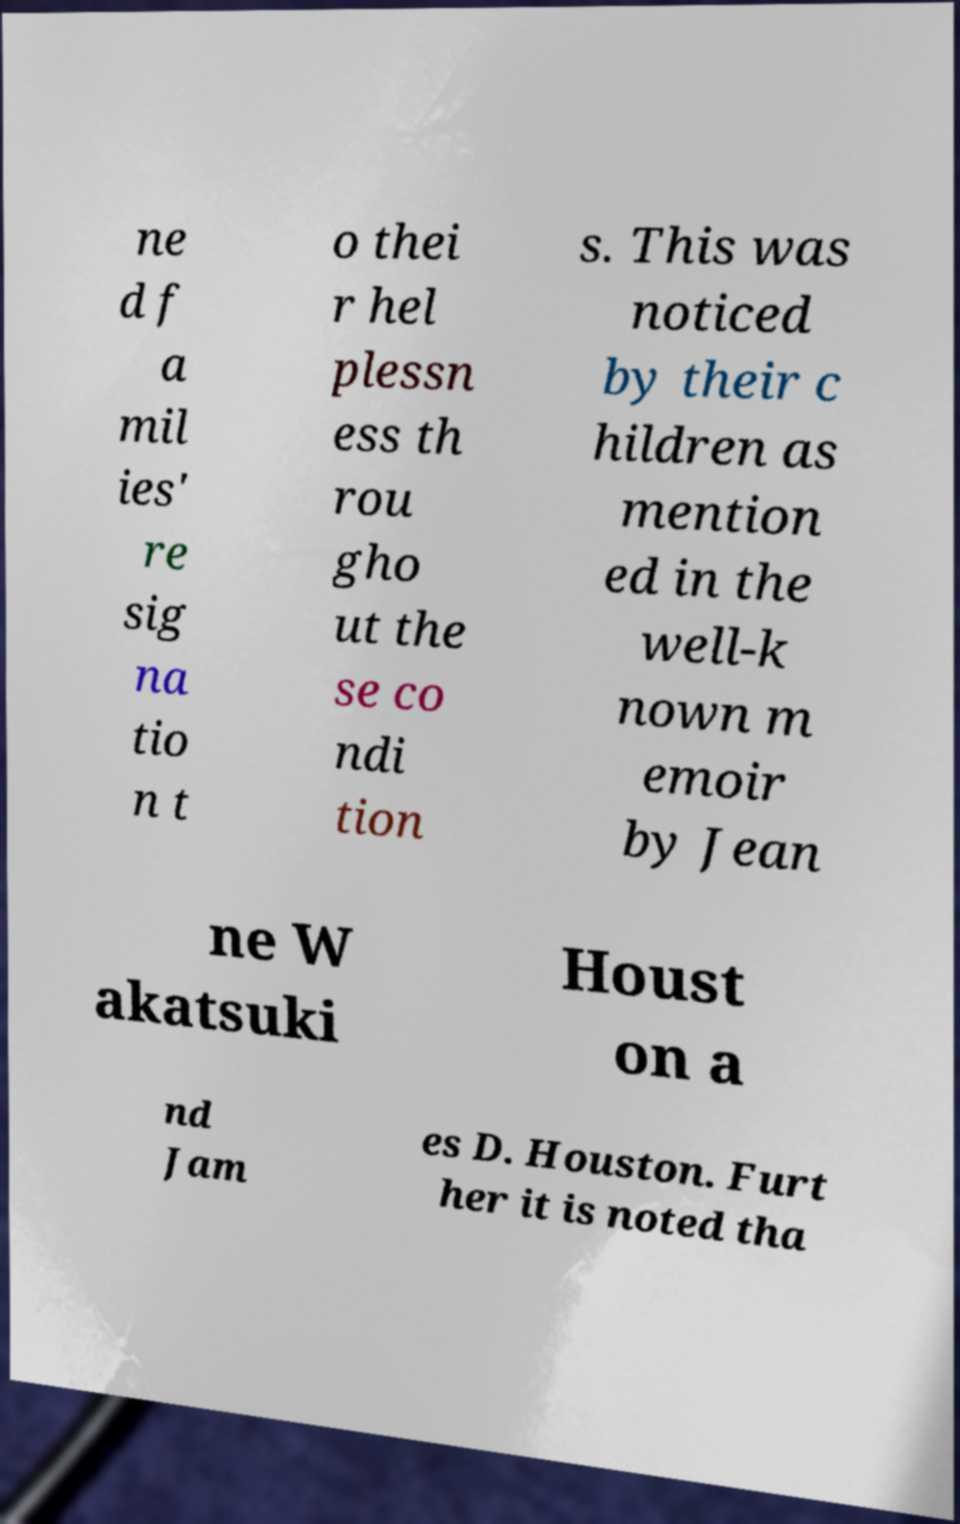There's text embedded in this image that I need extracted. Can you transcribe it verbatim? ne d f a mil ies' re sig na tio n t o thei r hel plessn ess th rou gho ut the se co ndi tion s. This was noticed by their c hildren as mention ed in the well-k nown m emoir by Jean ne W akatsuki Houst on a nd Jam es D. Houston. Furt her it is noted tha 